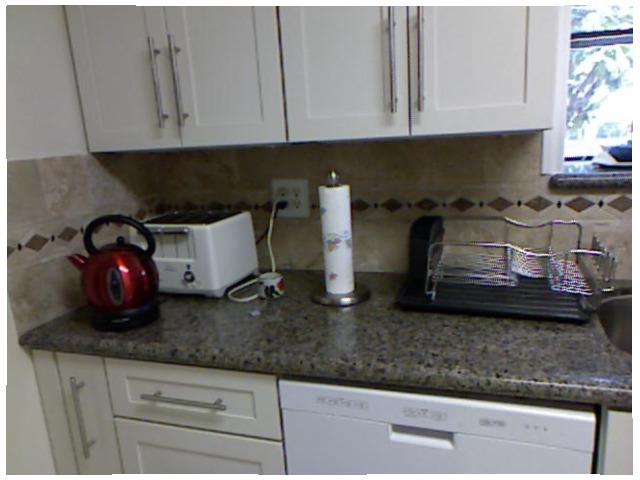<image>
Can you confirm if the toaster is under the kettle? No. The toaster is not positioned under the kettle. The vertical relationship between these objects is different. Where is the tea kettle in relation to the toaster? Is it in front of the toaster? Yes. The tea kettle is positioned in front of the toaster, appearing closer to the camera viewpoint. Where is the kettle in relation to the toaster? Is it in front of the toaster? Yes. The kettle is positioned in front of the toaster, appearing closer to the camera viewpoint. Is there a microwave on the shelf? No. The microwave is not positioned on the shelf. They may be near each other, but the microwave is not supported by or resting on top of the shelf. Where is the paper towel in relation to the toaster? Is it next to the toaster? Yes. The paper towel is positioned adjacent to the toaster, located nearby in the same general area. 